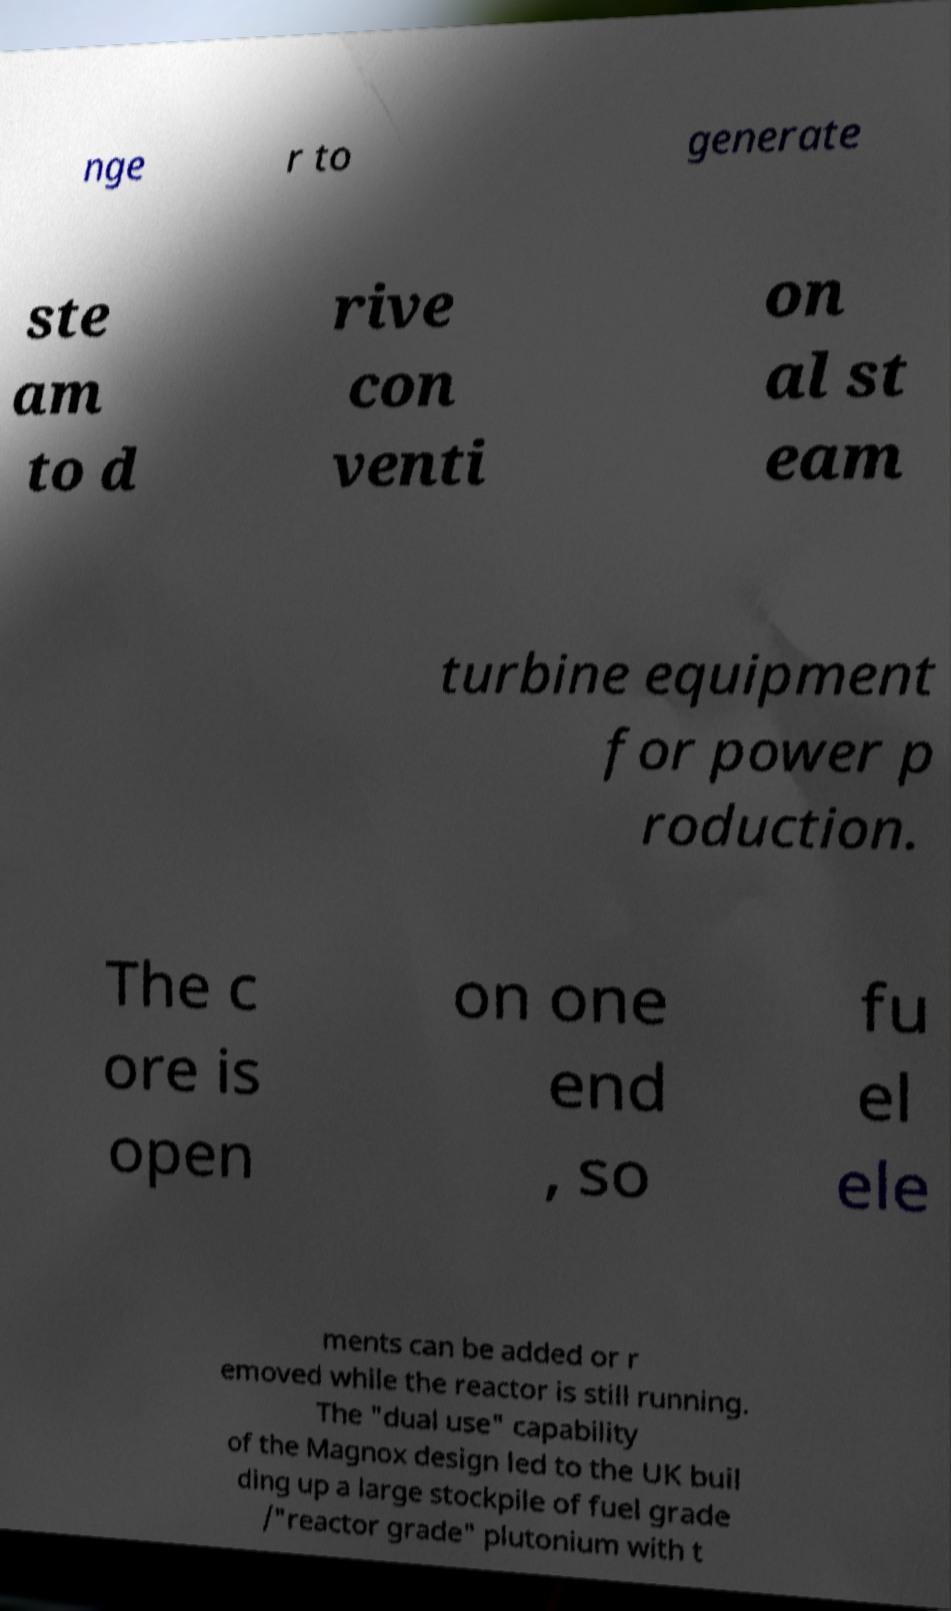Please read and relay the text visible in this image. What does it say? nge r to generate ste am to d rive con venti on al st eam turbine equipment for power p roduction. The c ore is open on one end , so fu el ele ments can be added or r emoved while the reactor is still running. The "dual use" capability of the Magnox design led to the UK buil ding up a large stockpile of fuel grade /"reactor grade" plutonium with t 